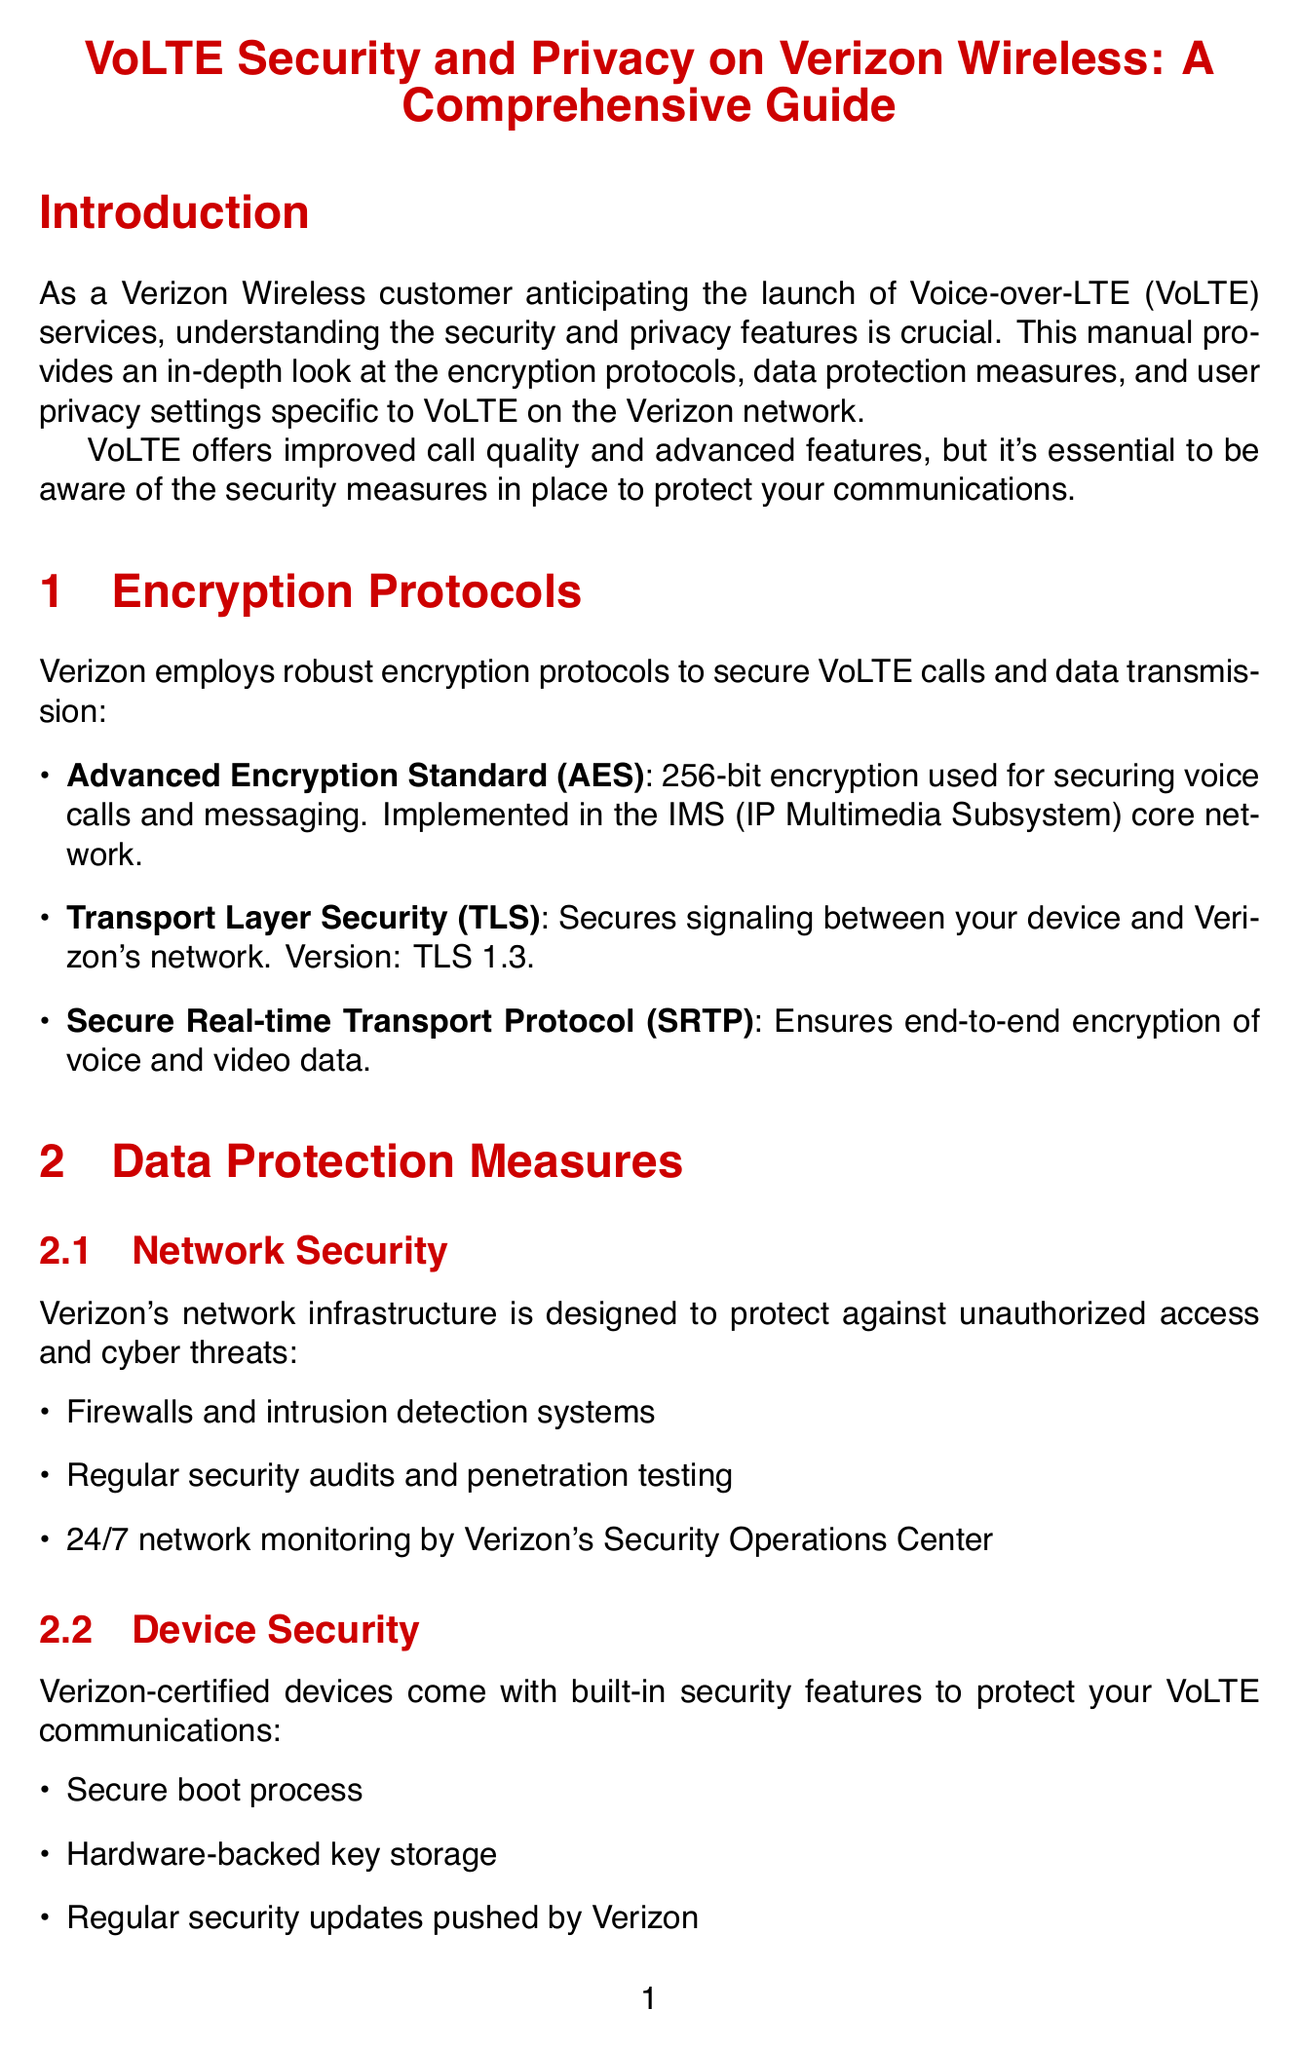What are the main encryption protocols used by Verizon for VoLTE? The main encryption protocols listed in the document for VoLTE are Advanced Encryption Standard (AES), Transport Layer Security (TLS), and Secure Real-time Transport Protocol (SRTP).
Answer: AES, TLS, SRTP What does AES stand for? AES is mentioned as Advanced Encryption Standard, which is a specific encryption standard used by Verizon.
Answer: Advanced Encryption Standard Which version of TLS is used by Verizon? The document specifies that TLS version 1.3 is implemented in Verizon's VoLTE services.
Answer: TLS 1.3 What is one of the data protection measures available for network security? The document lists several features, including firewalls and intrusion detection systems as a specific measure of network security.
Answer: Firewalls and intrusion detection systems How can a user hide their number when making outgoing calls? The manual indicates that a user can hide their number by dialing *67 before the number or enabling this feature in the My Verizon app.
Answer: Dial *67 What kind of authentication does Verizon offer for user account access? The document lists biometric authentication as one of the methods offered by Verizon to prevent unauthorized access.
Answer: Biometric authentication When should location services be on according to the document? The manual specifies that E911 location services are always on for emergency calls.
Answer: Emergency calls What are the best practices suggested for VoLTE users? The document includes several best practices, one of which is to regularly update device software and security patches.
Answer: Regularly update device's software and security patches Where can customers find more information about VoLTE security? The document provides specific online resources, including the Verizon Security Center and VoLTE FAQs, for customers seeking more information.
Answer: Verizon Security Center 